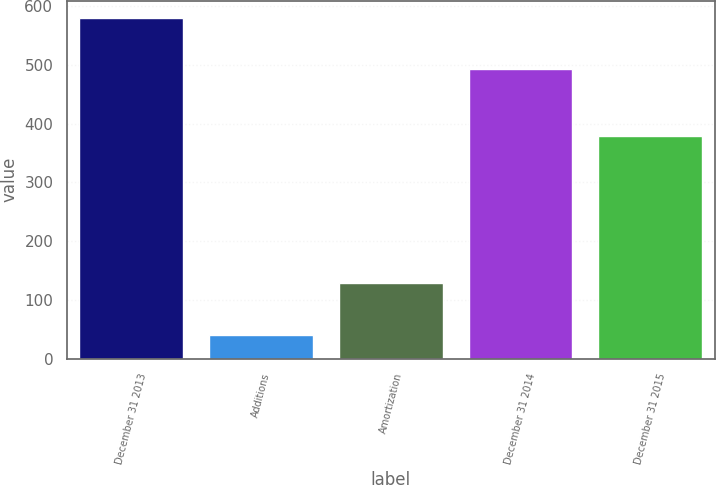<chart> <loc_0><loc_0><loc_500><loc_500><bar_chart><fcel>December 31 2013<fcel>Additions<fcel>Amortization<fcel>December 31 2014<fcel>December 31 2015<nl><fcel>580<fcel>41<fcel>128<fcel>493<fcel>379<nl></chart> 